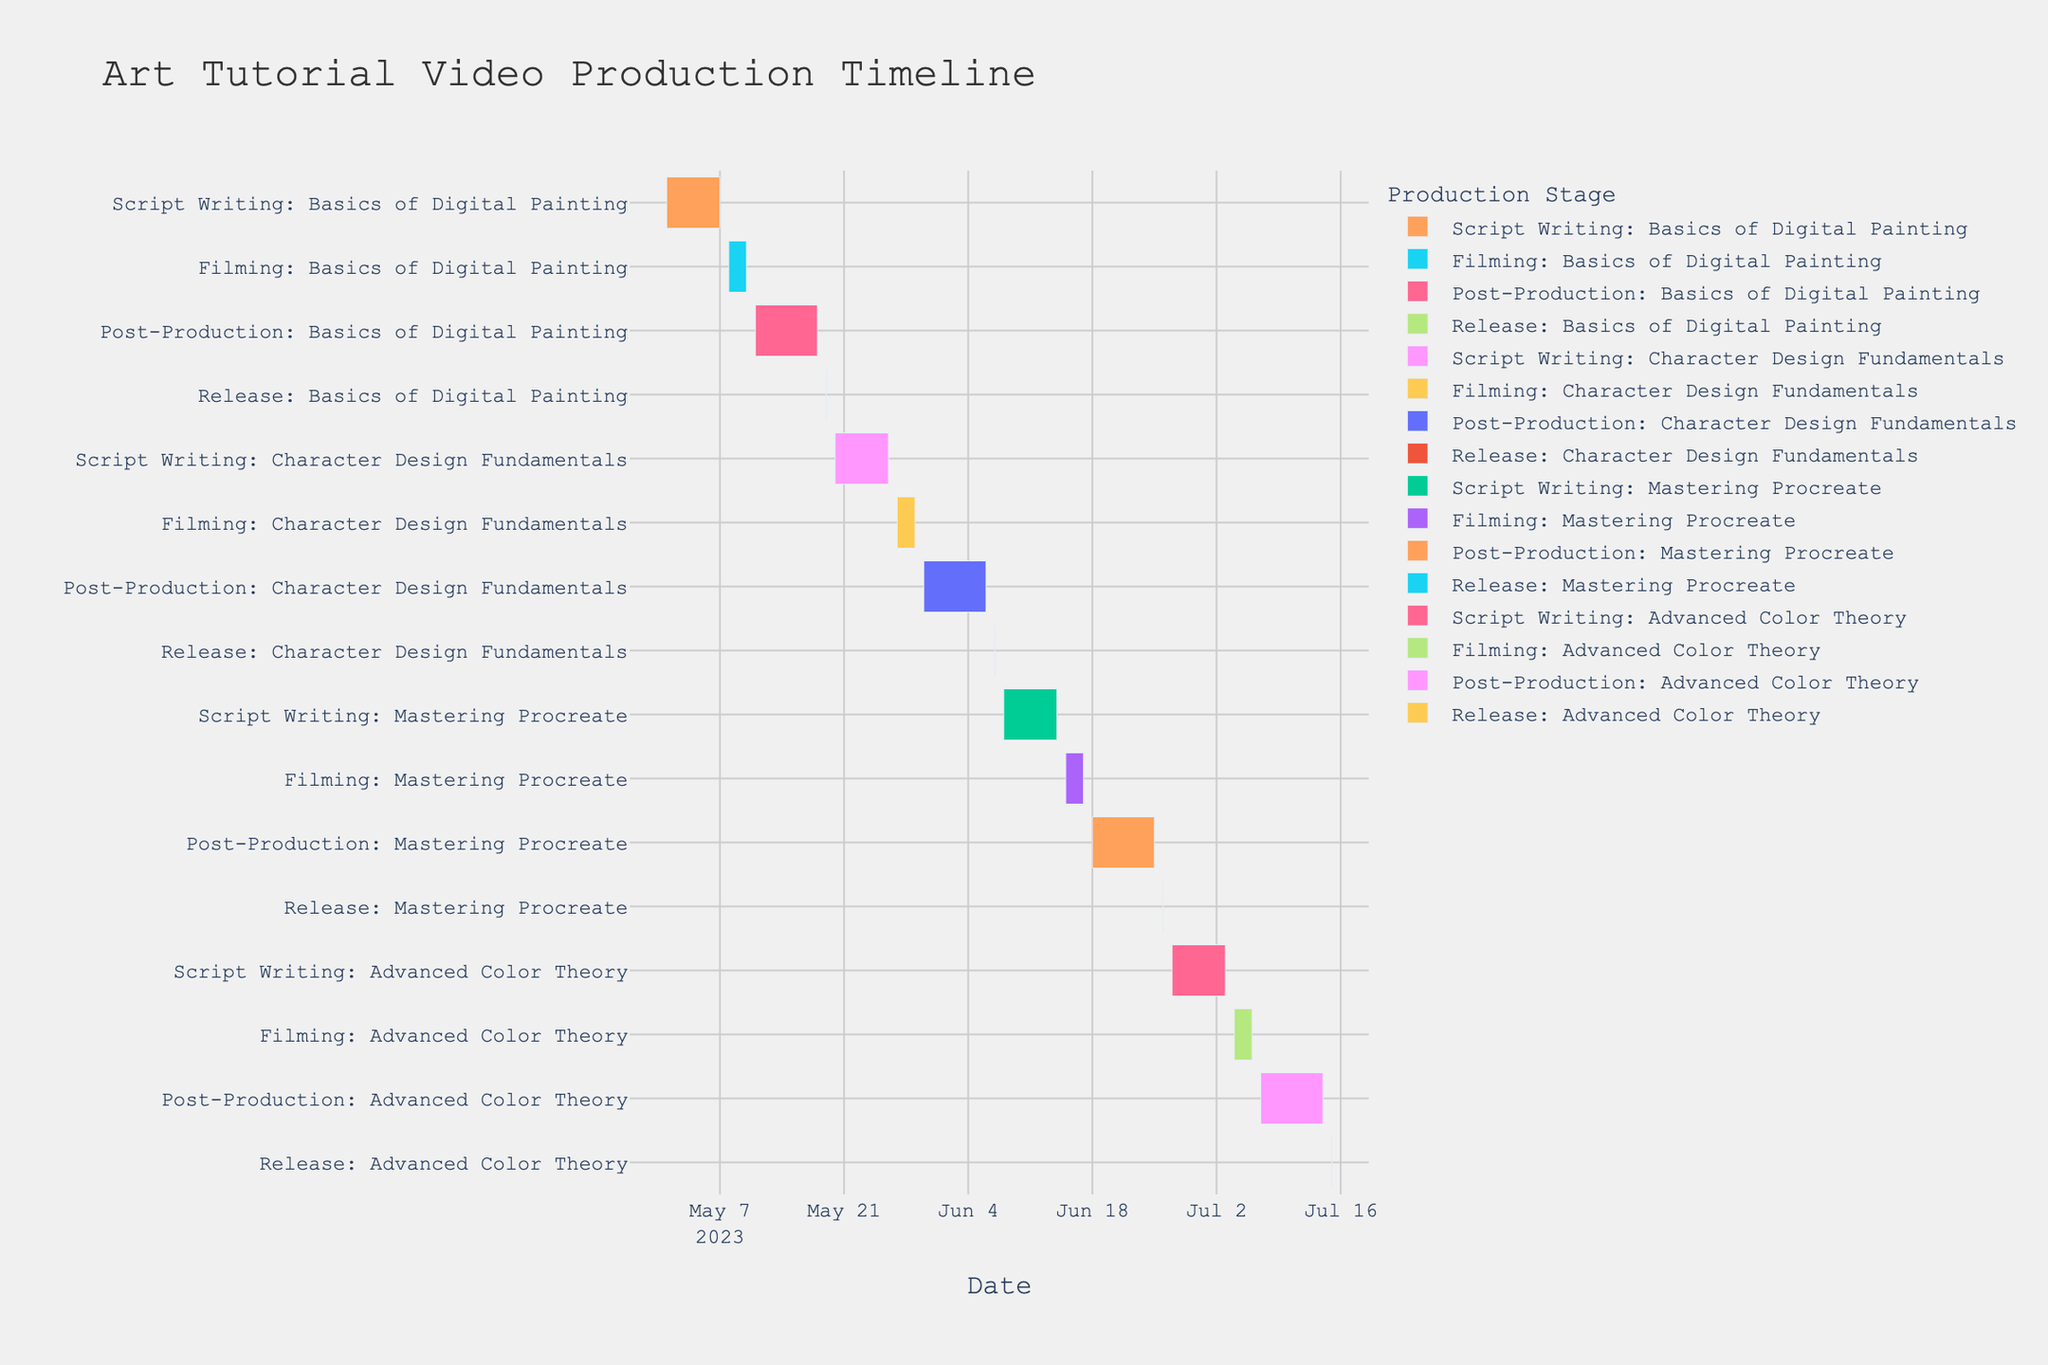What is the title of the Gantt chart? The title of a Gantt chart is typically found at the top center of the chart. In this case, it should directly state the purpose of the visualization.
Answer: Art Tutorial Video Production Timeline How many videos are being produced in total? Count the different sets of tasks (Script Writing, Filming, Post-Production, Release) for each video topic on the y-axis.
Answer: 4 Which task lasts the longest in the entire production timeline? Compare the duration of each task by looking at the length of each bar. The longest task will be the one with the longest bar on the x-axis from start to end date.
Answer: Post-Production: Basics of Digital Painting Which video has the shortest post-production phase? Observe the duration of the post-production phase for each video by comparing the length of the corresponding "Post-Production" bars.
Answer: Mastering Procreate When does scripting for "Character Design Fundamentals" begin and end? Identify the bar labeled "Script Writing: Character Design Fundamentals" and check its start and end dates.
Answer: May 20, 2023 - May 26, 2023 How many days are allocated for filming the "Advanced Color Theory" tutorial? Look at the filming phase for "Advanced Color Theory" and count the days between the start and end dates.
Answer: 3 days What is the time gap between the release of "Character Design Fundamentals" and the start of scripting for "Mastering Procreate"? Note the release date of "Character Design Fundamentals" and the start date of scripting for "Mastering Procreate," then calculate the difference in days between these two dates.
Answer: 1 day Which video has the earliest release date? Check the release dates for all videos and identify the earliest one.
Answer: Basics of Digital Painting What is the total duration of the entire production timeline from the start of the first task to the release of the last video? Find the start date of the first task and the end date of the last release, then calculate the total number of days between these dates.
Answer: 2023-05-01 to 2023-07-15 (75 days) Which task has the most number of days assigned on average across all videos? Calculate the average duration for each task type (Script Writing, Filming, Post-Production, Release) by summing their durations and dividing by the number of occurrences across all videos.
Answer: Post-Production 